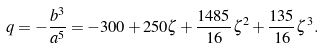<formula> <loc_0><loc_0><loc_500><loc_500>q = - \frac { b ^ { 3 } } { a ^ { 5 } } = - 3 0 0 + 2 5 0 \zeta + \frac { 1 4 8 5 } { 1 6 } \zeta ^ { 2 } + \frac { 1 3 5 } { 1 6 } \zeta ^ { 3 } .</formula> 